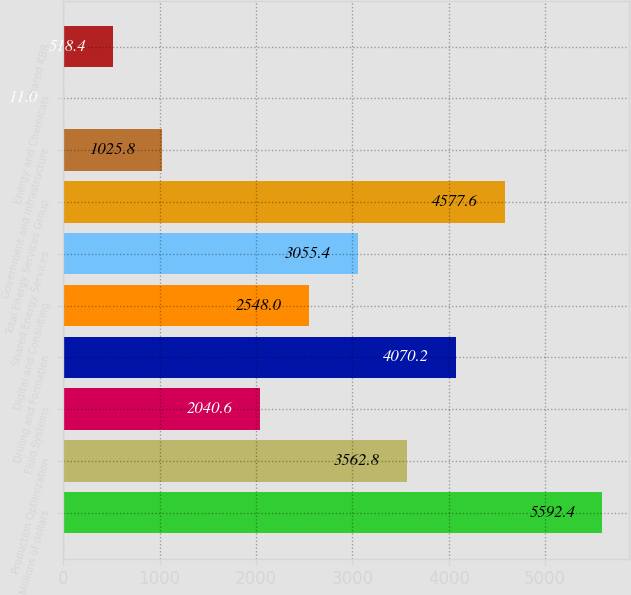Convert chart. <chart><loc_0><loc_0><loc_500><loc_500><bar_chart><fcel>Millions of dollars<fcel>Production Optimization<fcel>Fluid Systems<fcel>Drilling and Formation<fcel>Digital and Consulting<fcel>Shared Energy Services<fcel>Total Energy Services Group<fcel>Government and Infrastructure<fcel>Energy and Chemicals<fcel>Shared KBR<nl><fcel>5592.4<fcel>3562.8<fcel>2040.6<fcel>4070.2<fcel>2548<fcel>3055.4<fcel>4577.6<fcel>1025.8<fcel>11<fcel>518.4<nl></chart> 